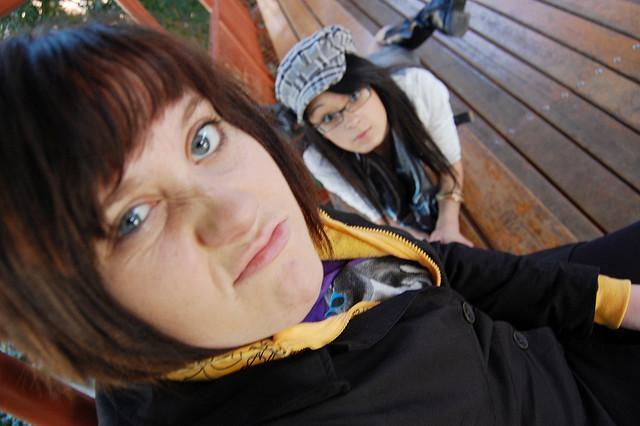How many people are visible?
Give a very brief answer. 2. 